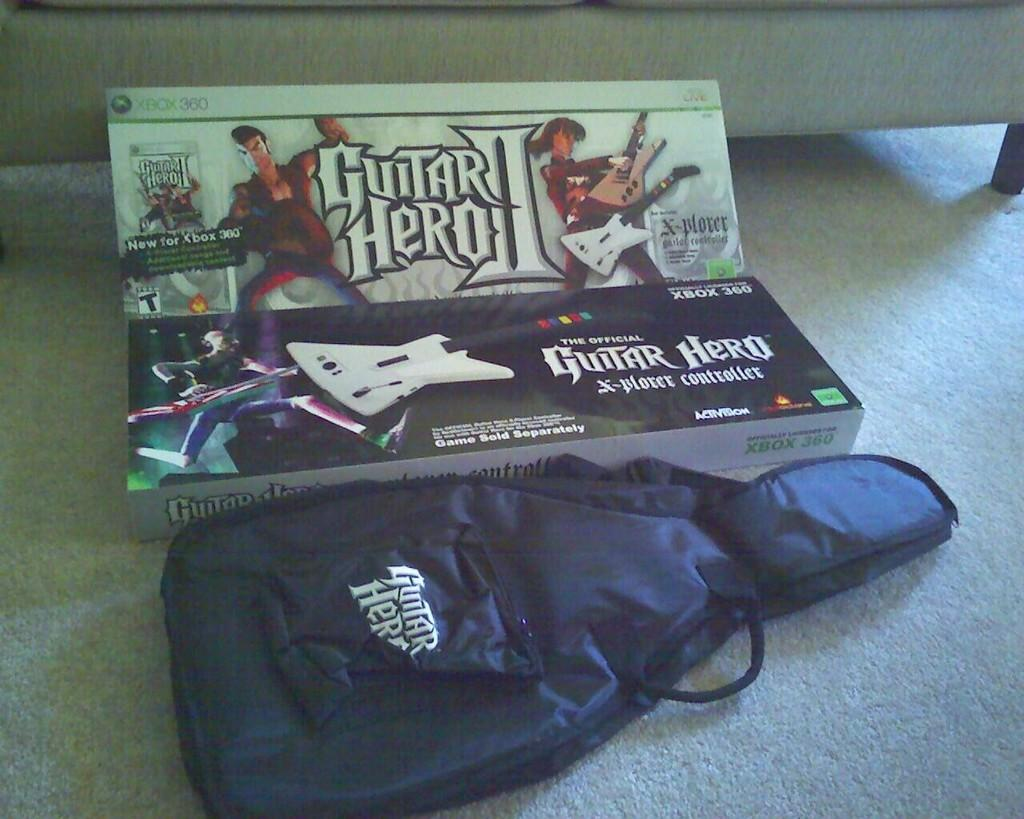What is the main object at the center of the image? There is a box at the center of the image. What musical instrument can be seen on the floor? There is a guitar on the floor. What type of furniture is visible in the background of the image? There is a sofa in the background of the image. What type of straw is used to play the guitar in the image? There is no straw present in the image, and the guitar is not being played. 